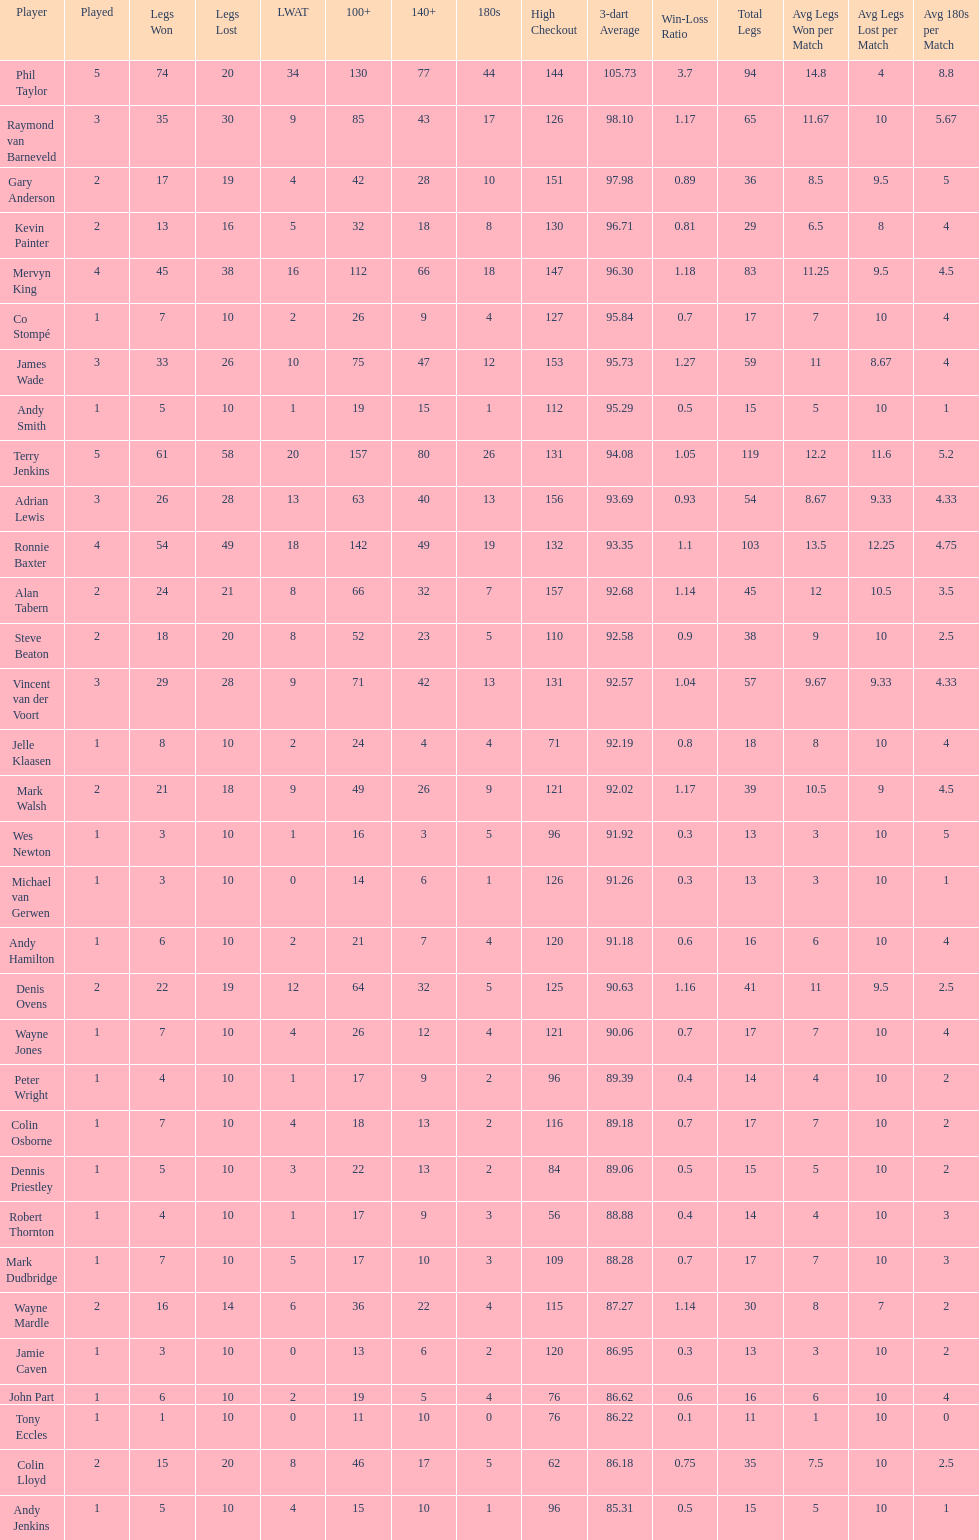What were the total number of legs won by ronnie baxter? 54. I'm looking to parse the entire table for insights. Could you assist me with that? {'header': ['Player', 'Played', 'Legs Won', 'Legs Lost', 'LWAT', '100+', '140+', '180s', 'High Checkout', '3-dart Average', 'Win-Loss Ratio', 'Total Legs', 'Avg Legs Won per Match', 'Avg Legs Lost per Match', 'Avg 180s per Match'], 'rows': [['Phil Taylor', '5', '74', '20', '34', '130', '77', '44', '144', '105.73', '3.7', '94', '14.8', '4', '8.8'], ['Raymond van Barneveld', '3', '35', '30', '9', '85', '43', '17', '126', '98.10', '1.17', '65', '11.67', '10', '5.67'], ['Gary Anderson', '2', '17', '19', '4', '42', '28', '10', '151', '97.98', '0.89', '36', '8.5', '9.5', '5'], ['Kevin Painter', '2', '13', '16', '5', '32', '18', '8', '130', '96.71', '0.81', '29', '6.5', '8', '4'], ['Mervyn King', '4', '45', '38', '16', '112', '66', '18', '147', '96.30', '1.18', '83', '11.25', '9.5', '4.5'], ['Co Stompé', '1', '7', '10', '2', '26', '9', '4', '127', '95.84', '0.7', '17', '7', '10', '4'], ['James Wade', '3', '33', '26', '10', '75', '47', '12', '153', '95.73', '1.27', '59', '11', '8.67', '4'], ['Andy Smith', '1', '5', '10', '1', '19', '15', '1', '112', '95.29', '0.5', '15', '5', '10', '1'], ['Terry Jenkins', '5', '61', '58', '20', '157', '80', '26', '131', '94.08', '1.05', '119', '12.2', '11.6', '5.2'], ['Adrian Lewis', '3', '26', '28', '13', '63', '40', '13', '156', '93.69', '0.93', '54', '8.67', '9.33', '4.33'], ['Ronnie Baxter', '4', '54', '49', '18', '142', '49', '19', '132', '93.35', '1.1', '103', '13.5', '12.25', '4.75'], ['Alan Tabern', '2', '24', '21', '8', '66', '32', '7', '157', '92.68', '1.14', '45', '12', '10.5', '3.5'], ['Steve Beaton', '2', '18', '20', '8', '52', '23', '5', '110', '92.58', '0.9', '38', '9', '10', '2.5'], ['Vincent van der Voort', '3', '29', '28', '9', '71', '42', '13', '131', '92.57', '1.04', '57', '9.67', '9.33', '4.33'], ['Jelle Klaasen', '1', '8', '10', '2', '24', '4', '4', '71', '92.19', '0.8', '18', '8', '10', '4'], ['Mark Walsh', '2', '21', '18', '9', '49', '26', '9', '121', '92.02', '1.17', '39', '10.5', '9', '4.5'], ['Wes Newton', '1', '3', '10', '1', '16', '3', '5', '96', '91.92', '0.3', '13', '3', '10', '5'], ['Michael van Gerwen', '1', '3', '10', '0', '14', '6', '1', '126', '91.26', '0.3', '13', '3', '10', '1'], ['Andy Hamilton', '1', '6', '10', '2', '21', '7', '4', '120', '91.18', '0.6', '16', '6', '10', '4'], ['Denis Ovens', '2', '22', '19', '12', '64', '32', '5', '125', '90.63', '1.16', '41', '11', '9.5', '2.5'], ['Wayne Jones', '1', '7', '10', '4', '26', '12', '4', '121', '90.06', '0.7', '17', '7', '10', '4'], ['Peter Wright', '1', '4', '10', '1', '17', '9', '2', '96', '89.39', '0.4', '14', '4', '10', '2'], ['Colin Osborne', '1', '7', '10', '4', '18', '13', '2', '116', '89.18', '0.7', '17', '7', '10', '2'], ['Dennis Priestley', '1', '5', '10', '3', '22', '13', '2', '84', '89.06', '0.5', '15', '5', '10', '2'], ['Robert Thornton', '1', '4', '10', '1', '17', '9', '3', '56', '88.88', '0.4', '14', '4', '10', '3'], ['Mark Dudbridge', '1', '7', '10', '5', '17', '10', '3', '109', '88.28', '0.7', '17', '7', '10', '3'], ['Wayne Mardle', '2', '16', '14', '6', '36', '22', '4', '115', '87.27', '1.14', '30', '8', '7', '2'], ['Jamie Caven', '1', '3', '10', '0', '13', '6', '2', '120', '86.95', '0.3', '13', '3', '10', '2'], ['John Part', '1', '6', '10', '2', '19', '5', '4', '76', '86.62', '0.6', '16', '6', '10', '4'], ['Tony Eccles', '1', '1', '10', '0', '11', '10', '0', '76', '86.22', '0.1', '11', '1', '10', '0'], ['Colin Lloyd', '2', '15', '20', '8', '46', '17', '5', '62', '86.18', '0.75', '35', '7.5', '10', '2.5'], ['Andy Jenkins', '1', '5', '10', '4', '15', '10', '1', '96', '85.31', '0.5', '15', '5', '10', '1']]} 